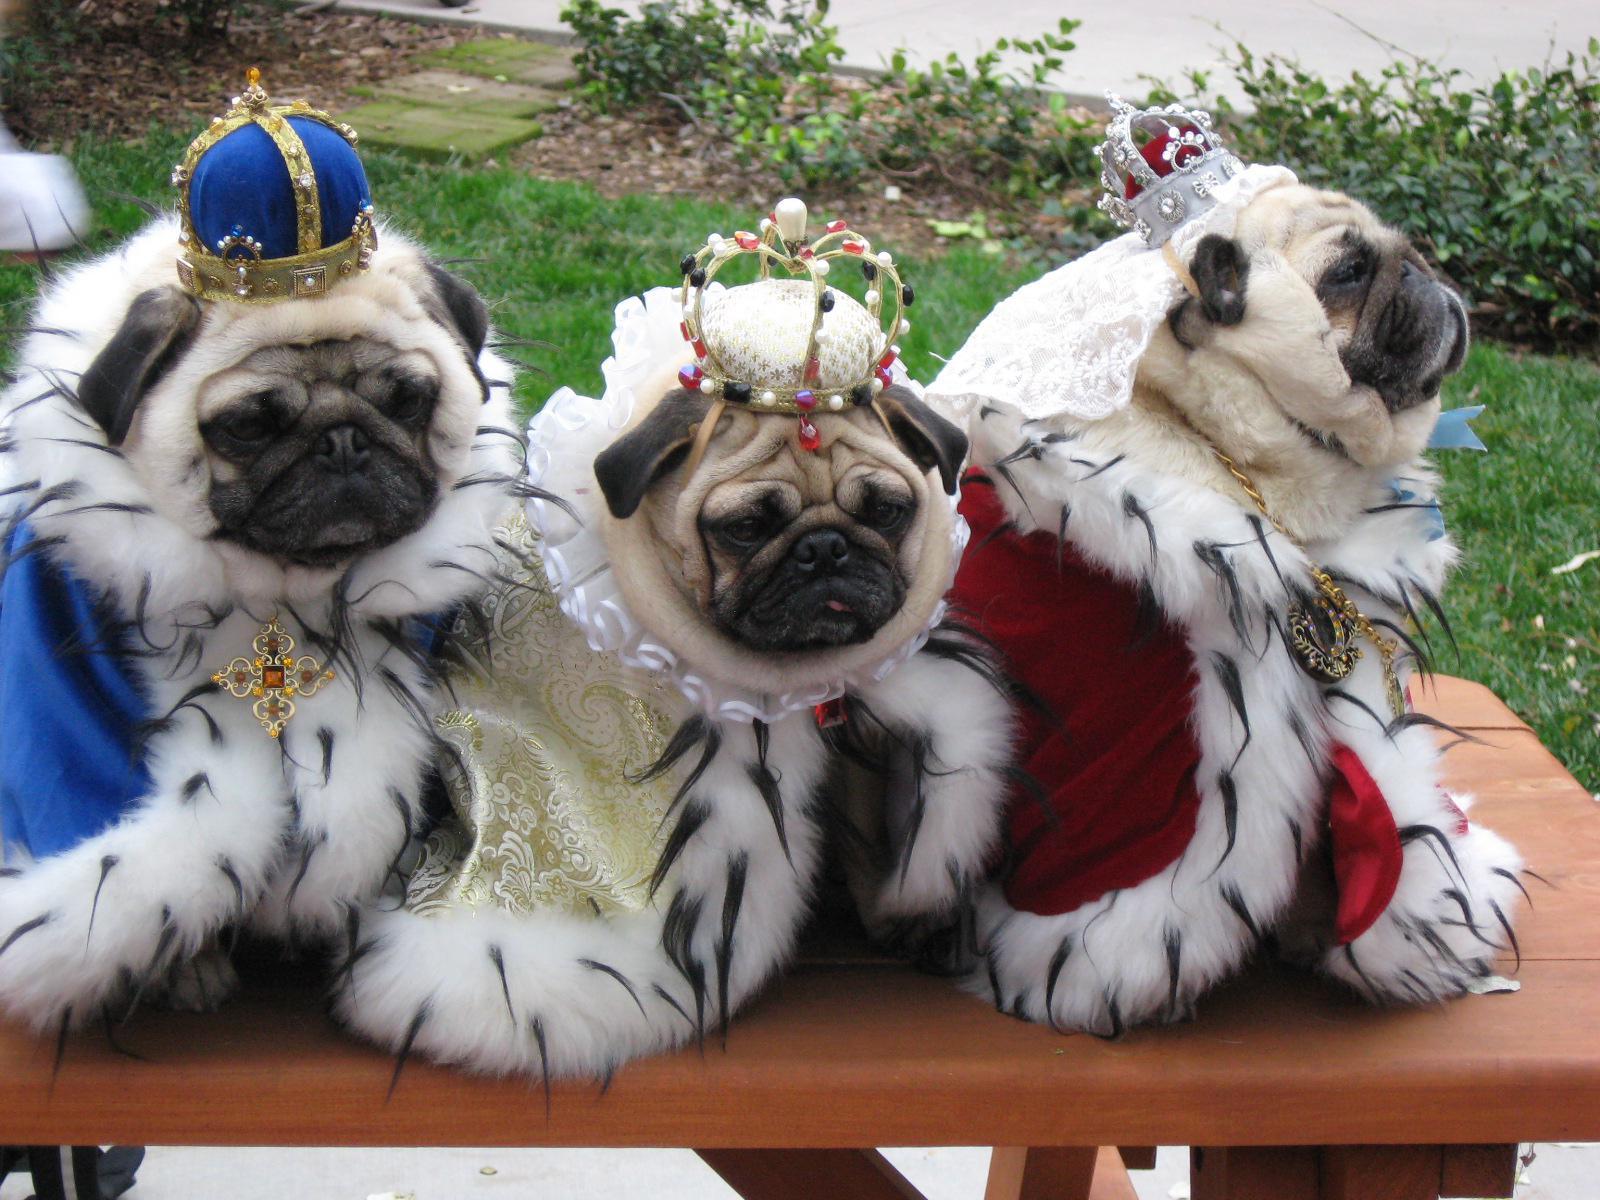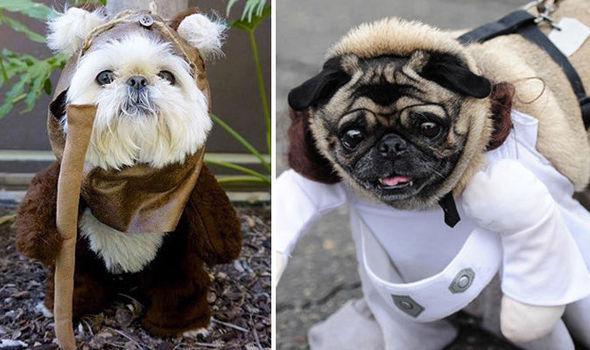The first image is the image on the left, the second image is the image on the right. Evaluate the accuracy of this statement regarding the images: "A total of five dogs are shown, and all dogs are wearing some type of attire other than an ordinary dog collar.". Is it true? Answer yes or no. Yes. The first image is the image on the left, the second image is the image on the right. Given the left and right images, does the statement "All the dogs in the images are tan pugs." hold true? Answer yes or no. No. 